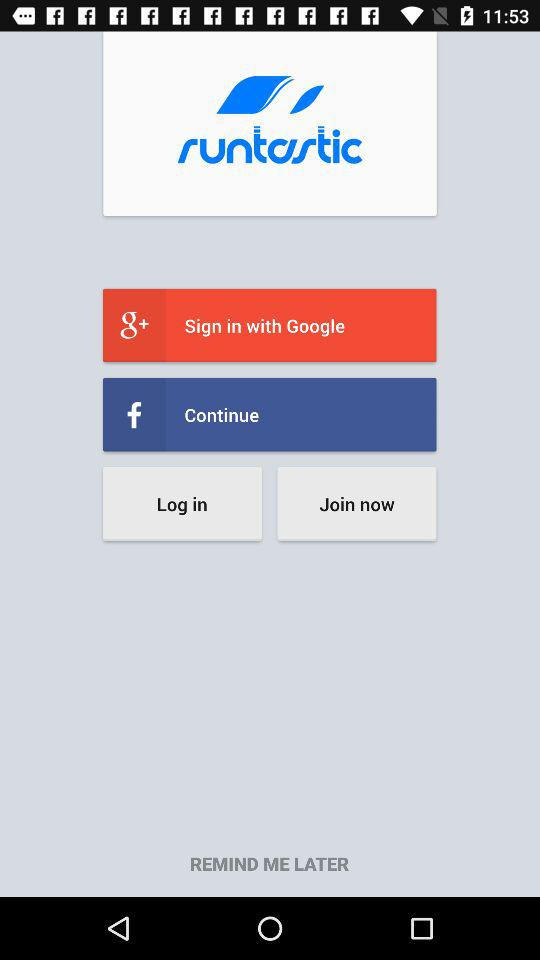What's the sign in option there? The sign in option is Google. 